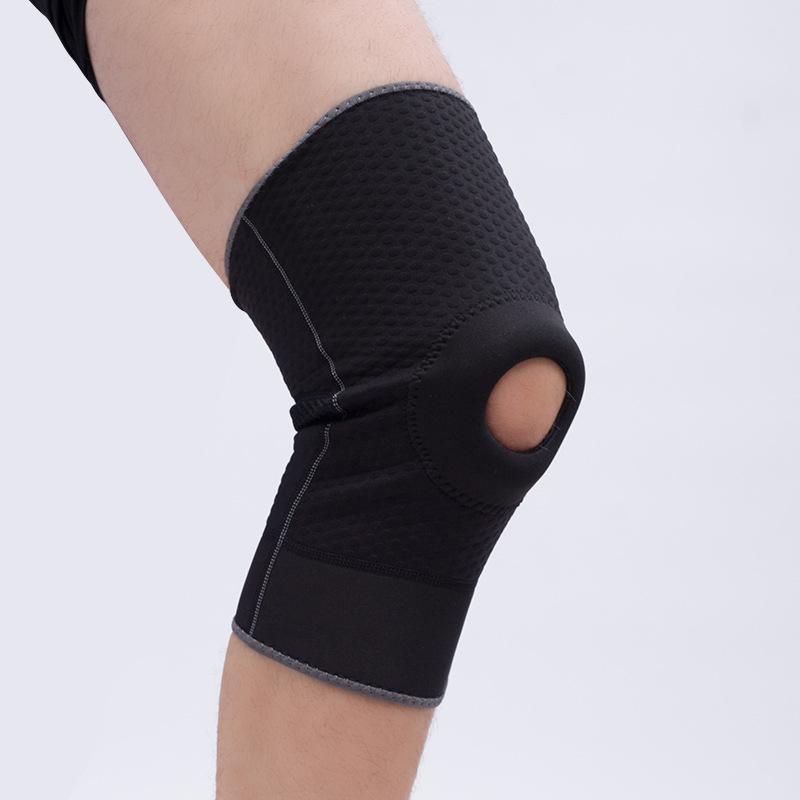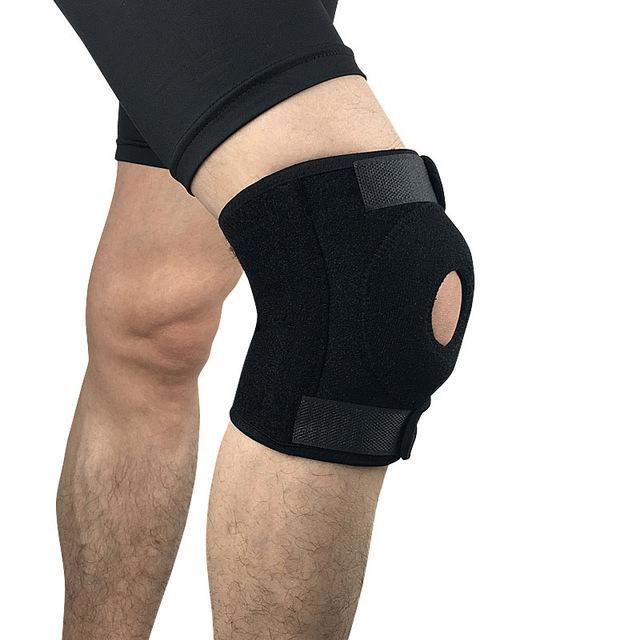The first image is the image on the left, the second image is the image on the right. Analyze the images presented: Is the assertion "In each image, a single black kneepad on a human leg is made with a round hole at the center of the knee." valid? Answer yes or no. Yes. The first image is the image on the left, the second image is the image on the right. Given the left and right images, does the statement "Every knee pad has a hole at the kneecap area." hold true? Answer yes or no. Yes. 